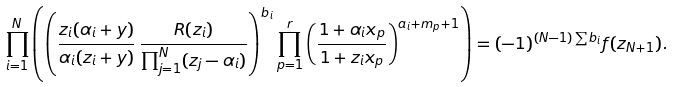<formula> <loc_0><loc_0><loc_500><loc_500>\prod _ { i = 1 } ^ { N } \left ( \left ( \frac { z _ { i } ( \alpha _ { i } + y ) } { \alpha _ { i } ( z _ { i } + y ) } \, \frac { R ( z _ { i } ) } { \prod _ { j = 1 } ^ { N } ( z _ { j } - \alpha _ { i } ) } \right ) ^ { b _ { i } } \prod _ { p = 1 } ^ { r } \left ( \frac { 1 + \alpha _ { i } x _ { p } } { 1 + z _ { i } x _ { p } } \right ) ^ { a _ { i } + m _ { p } + 1 } \right ) = ( - 1 ) ^ { ( N - 1 ) \sum b _ { i } } f ( z _ { N + 1 } ) .</formula> 